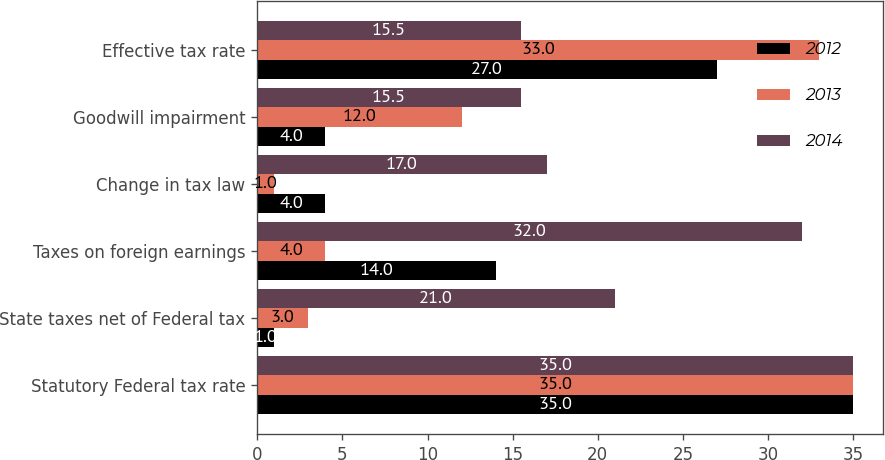<chart> <loc_0><loc_0><loc_500><loc_500><stacked_bar_chart><ecel><fcel>Statutory Federal tax rate<fcel>State taxes net of Federal tax<fcel>Taxes on foreign earnings<fcel>Change in tax law<fcel>Goodwill impairment<fcel>Effective tax rate<nl><fcel>2012<fcel>35<fcel>1<fcel>14<fcel>4<fcel>4<fcel>27<nl><fcel>2013<fcel>35<fcel>3<fcel>4<fcel>1<fcel>12<fcel>33<nl><fcel>2014<fcel>35<fcel>21<fcel>32<fcel>17<fcel>15.5<fcel>15.5<nl></chart> 